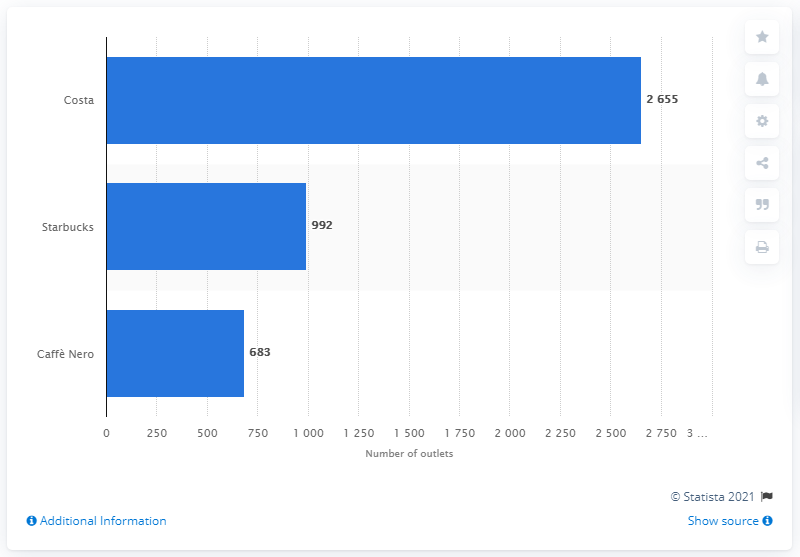Mention a couple of crucial points in this snapshot. In January 2019, Starbucks had a total of 992 stores in the UK. Starbucks was the only non-British company to have a presence in the UK. According to the information available as of January 2019, Costa was the largest coffee chain in the UK in terms of the number of outlets. 